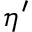<formula> <loc_0><loc_0><loc_500><loc_500>\eta ^ { \prime }</formula> 